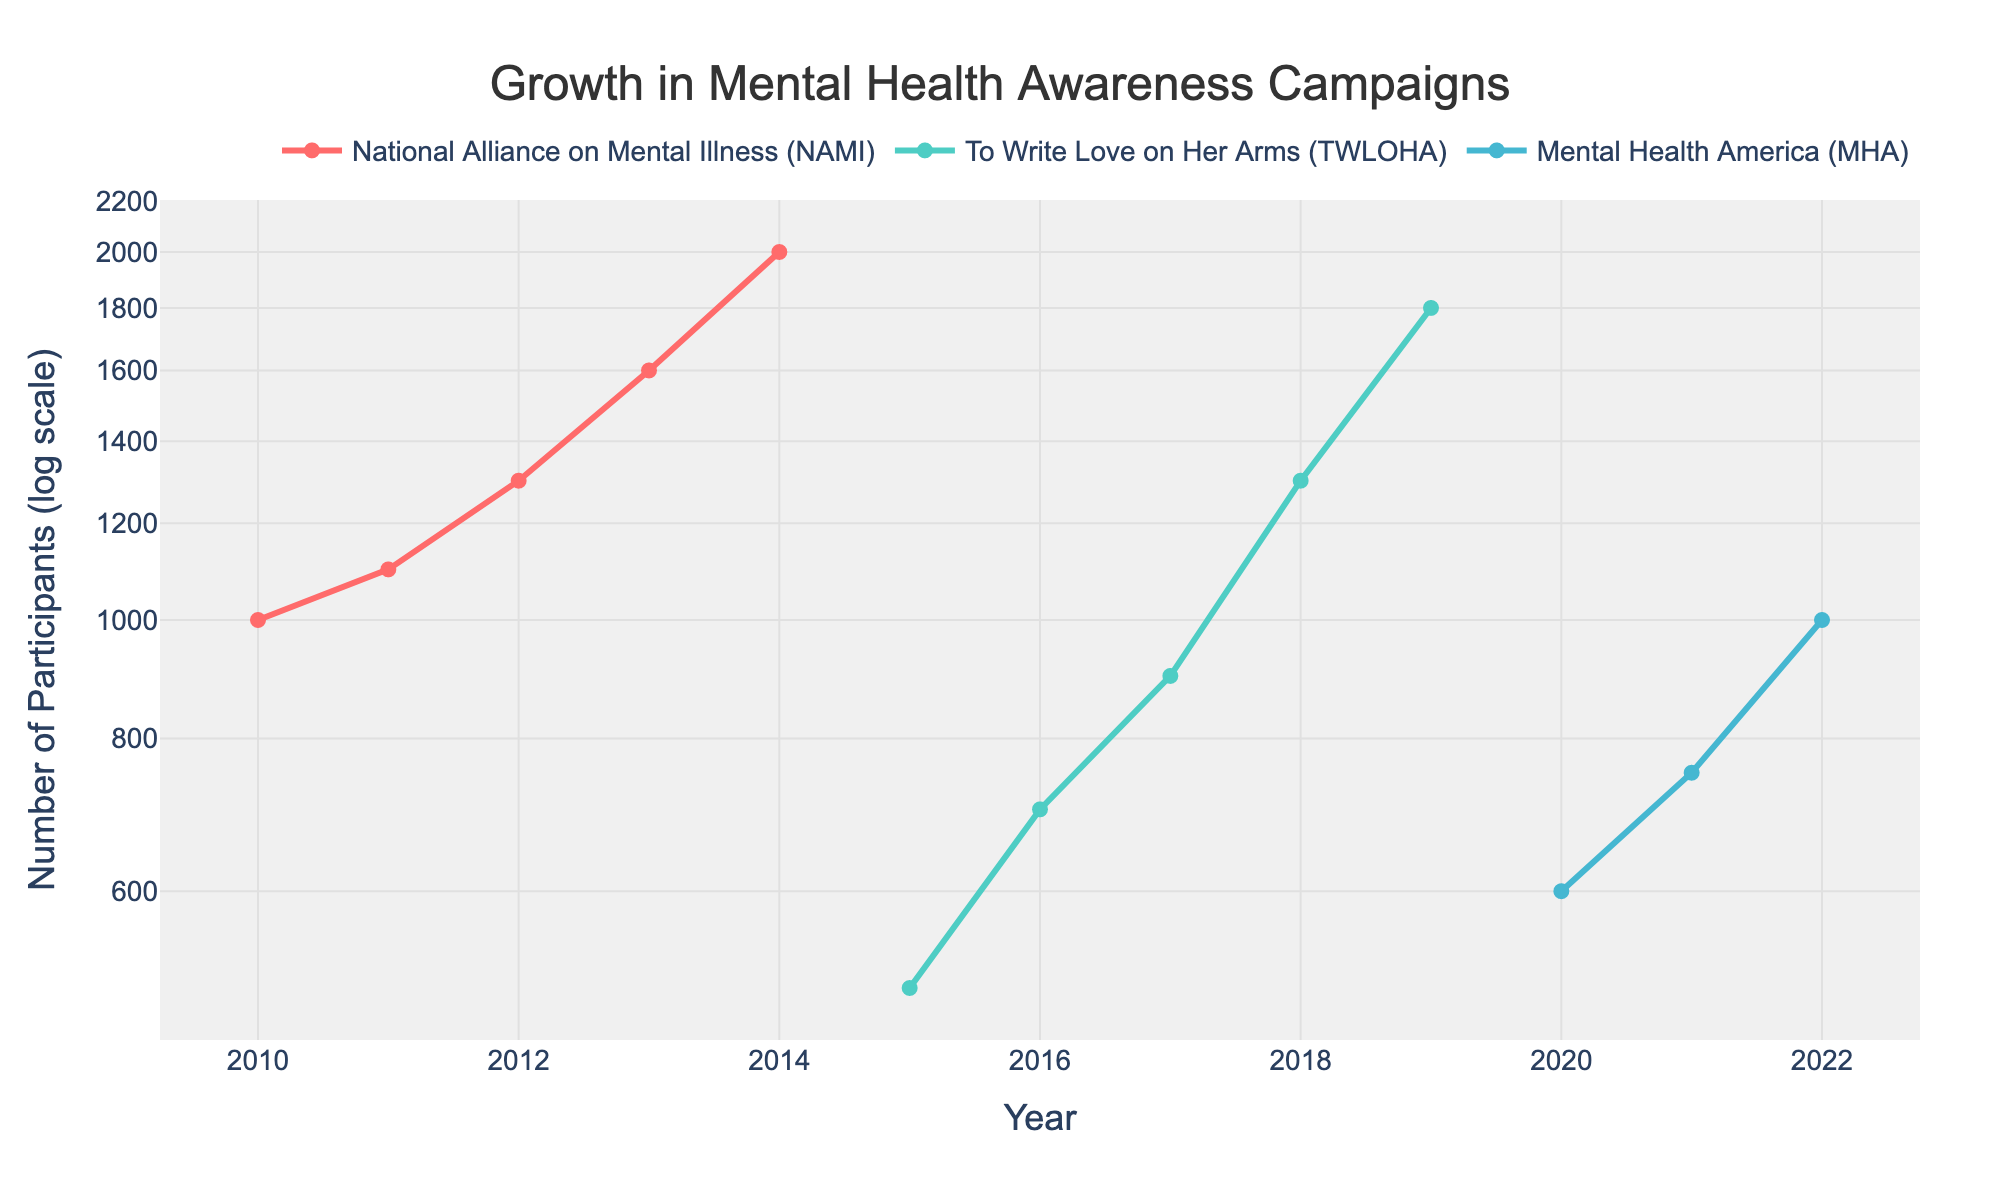What's the title of the figure? The title is located at the top of the plot and it summarizes the main subject of the figure. It reads "Growth in Mental Health Awareness Campaigns".
Answer: Growth in Mental Health Awareness Campaigns What are the organizations represented in the figure? By looking at the legend or color labels, you can see that there are three organizations: National Alliance on Mental Illness (NAMI), To Write Love on Her Arms (TWLOHA), and Mental Health America (MHA).
Answer: National Alliance on Mental Illness (NAMI), To Write Love on Her Arms (TWLOHA), Mental Health America (MHA) In what year did 'To Write Love on Her Arms' (TWLOHA) have the highest participation rate? Locate the 'To Write Love on Her Arms' (TWLOHA) line, which is uniquely colored, and identify the year with the highest marker on the y-axis for this line. This occurs in 2019.
Answer: 2019 How many participants did 'Mental Health America' (MHA) have in 2022? Find the data point for 'Mental Health America' (MHA) in 2022. The y-axis value for this coordinate represents the number of participants. It is 1000 participants.
Answer: 1000 participants Compare the participants in the year 2015 for NAMI and TWLOHA. Which had more participants and by how much? For 2015, find the y-axis value for both NAMI and TWLOHA. NAMI had 2000 participants while TWLOHA had 500 participants. The difference is 2000 - 500 = 1500 participants. So, NAMI had 1500 more participants than TWLOHA in 2015.
Answer: NAMI had 1500 more participants By what percentage did the number of participants for 'National Alliance on Mental Illness' (NAMI) increase from 2011 to 2012? NAMI's participants in 2011 were 1100 and in 2012 were 1300. The percentage increase is calculated as ((1300 - 1100) / 1100) * 100 = 18.18%.
Answer: 18.18% Between 2020 and 2021, how much did the number of participants in 'Mental Health America' (MHA) change? Examine the y-values for MHA in 2020 and 2021. MHA had 600 participants in 2020 and 750 in 2021. The change is 750 - 600 = 150 participants.
Answer: Increased by 150 participants Which organization showed the fastest growth in participation rates by the end of the time period shown? By identifying the slopes of the lines towards the end of the plot, observe that 'Mental Health America' (MHA) had the steepest line, indicating the fastest rate of growth in participant numbers by 2022.
Answer: Mental Health America (MHA) How many total data points are there in the plot? Count the individual data points shown for each line. NAMI has data points for 2010-2014 (5 points), TWLOHA for 2015-2019 (5 points), and MHA for 2020-2022 (3 points). The total is 5 + 5 + 3 = 13 data points.
Answer: 13 data points 